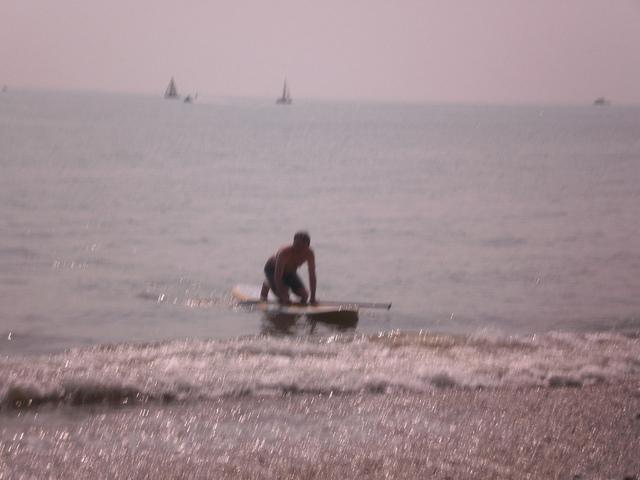How many full red umbrellas are visible in the image?
Give a very brief answer. 0. 